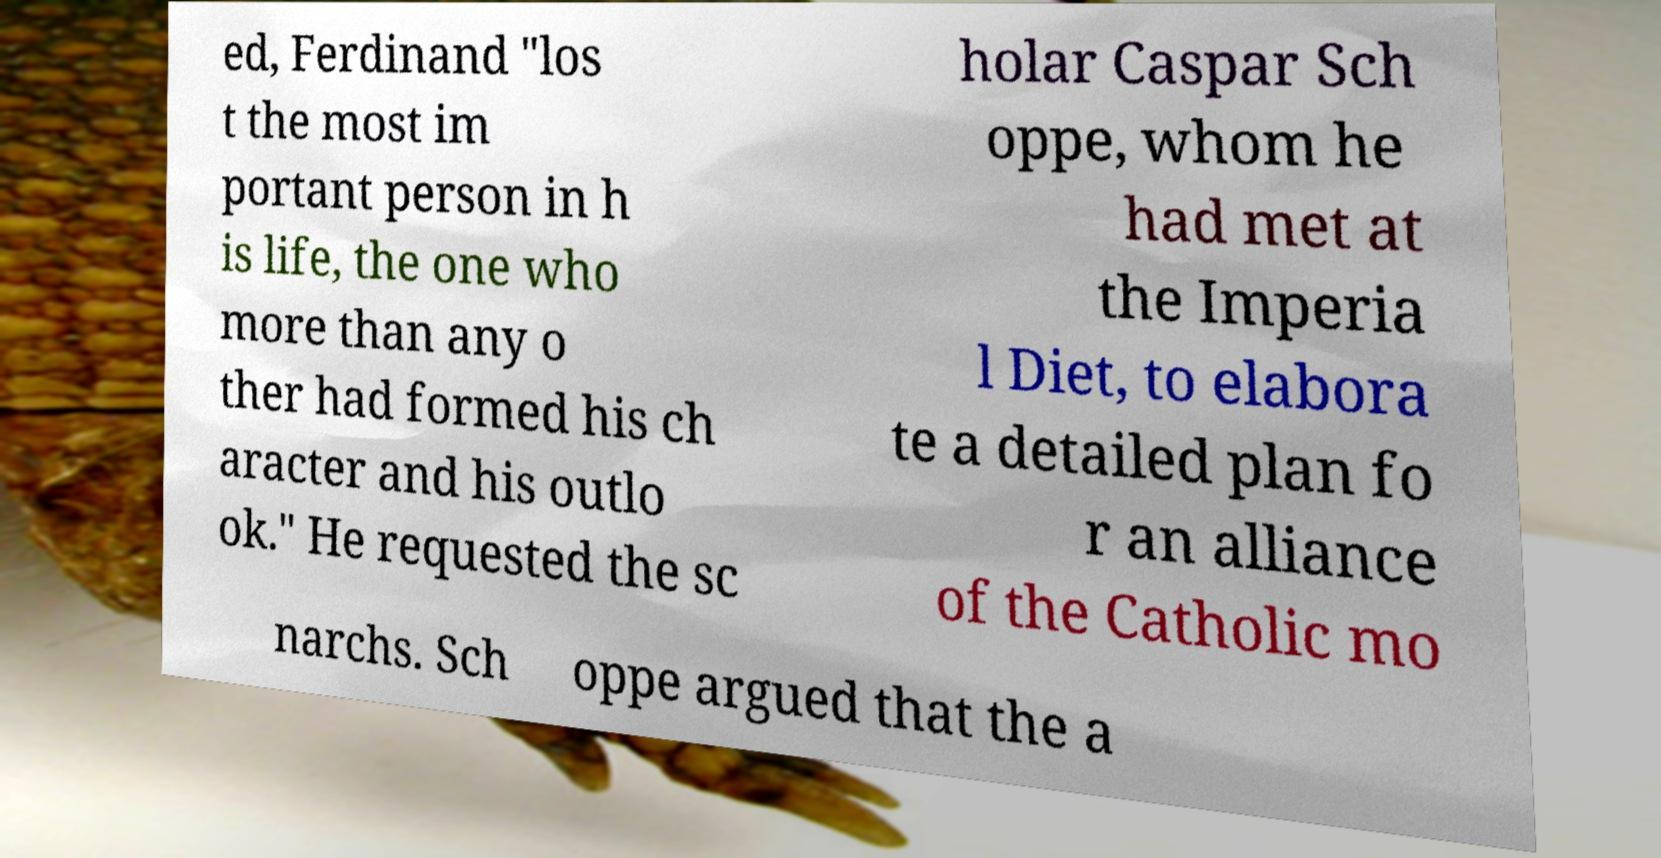What messages or text are displayed in this image? I need them in a readable, typed format. ed, Ferdinand "los t the most im portant person in h is life, the one who more than any o ther had formed his ch aracter and his outlo ok." He requested the sc holar Caspar Sch oppe, whom he had met at the Imperia l Diet, to elabora te a detailed plan fo r an alliance of the Catholic mo narchs. Sch oppe argued that the a 